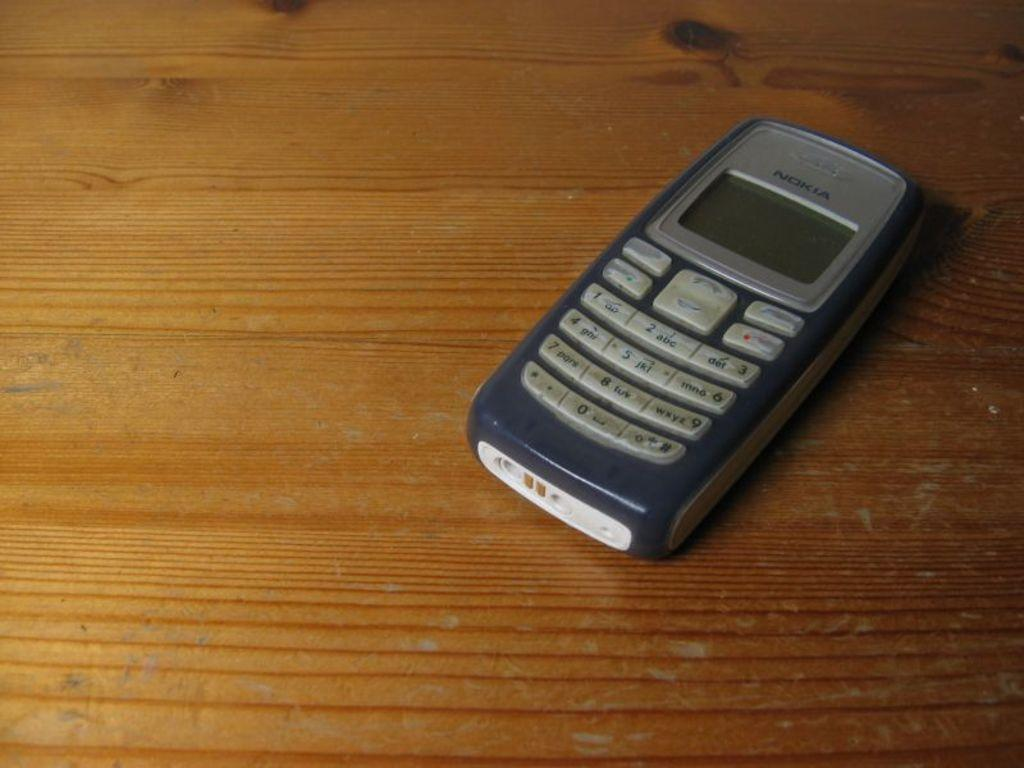<image>
Share a concise interpretation of the image provided. A blue and gray Nokia cell phone lies on a wood table. 